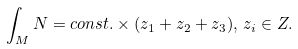Convert formula to latex. <formula><loc_0><loc_0><loc_500><loc_500>\int _ { M } N = c o n s t . \times ( z _ { 1 } + z _ { 2 } + z _ { 3 } ) , \, z _ { i } \in { Z } .</formula> 